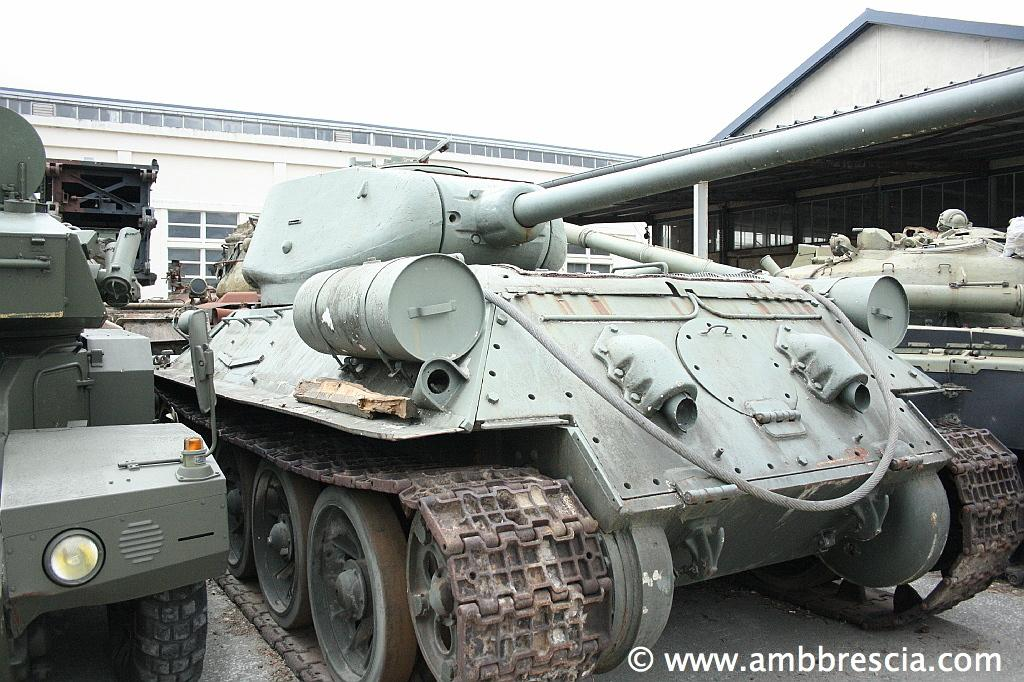What types of objects are present in the image? There are vehicles and buildings in the image. What part of the natural environment is visible in the image? The sky is visible in the image. What type of shade is provided by the frog in the image? There is no frog present in the image, so it is not possible to determine what type of shade it might provide. Can you describe the feather on the vehicle in the image? There are no feathers present on any of the vehicles in the image. 